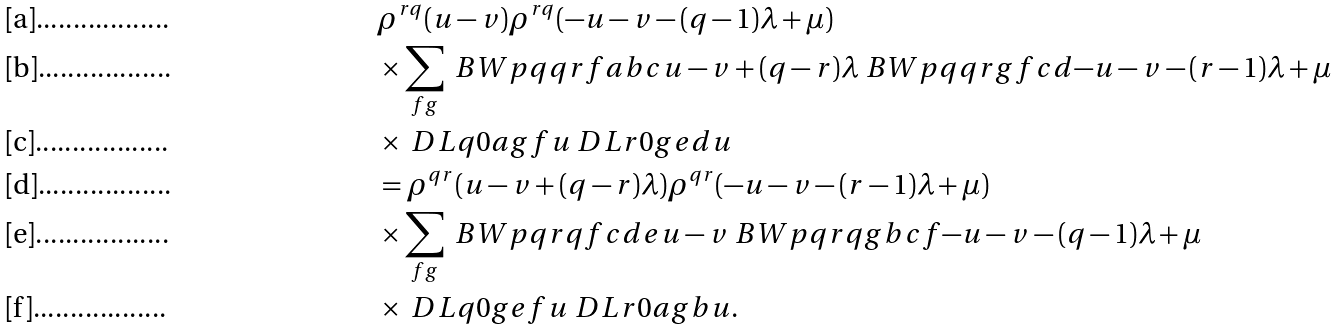Convert formula to latex. <formula><loc_0><loc_0><loc_500><loc_500>& \rho ^ { r q } ( u - v ) \rho ^ { r q } ( - u - v - ( q - 1 ) \lambda + \mu ) \\ & \times \sum _ { f g } \ B W p q { q } { r } { f } { a } { b } { c } { u - v + ( q - r ) \lambda } \ B W p q { q } { r } { g } { f } { c } { d } { - u - v - ( r - 1 ) \lambda + \mu } \\ & \times \ D L { q } { 0 } { a } { g } { f } { u } \ D L { r } { 0 } { g } { e } { d } { u } \\ & = \rho ^ { q r } ( u - v + ( q - r ) \lambda ) \rho ^ { q r } ( - u - v - ( r - 1 ) \lambda + \mu ) \\ & \times \sum _ { f g } \ B W p q { r } { q } { f } { c } { d } { e } { u - v } \ B W p q { r } { q } { g } { b } { c } { f } { - u - v - ( q - 1 ) \lambda + \mu } \\ & \times \ D L { q } { 0 } { g } { e } { f } { u } \ D L { r } { 0 } { a } { g } { b } { u } .</formula> 